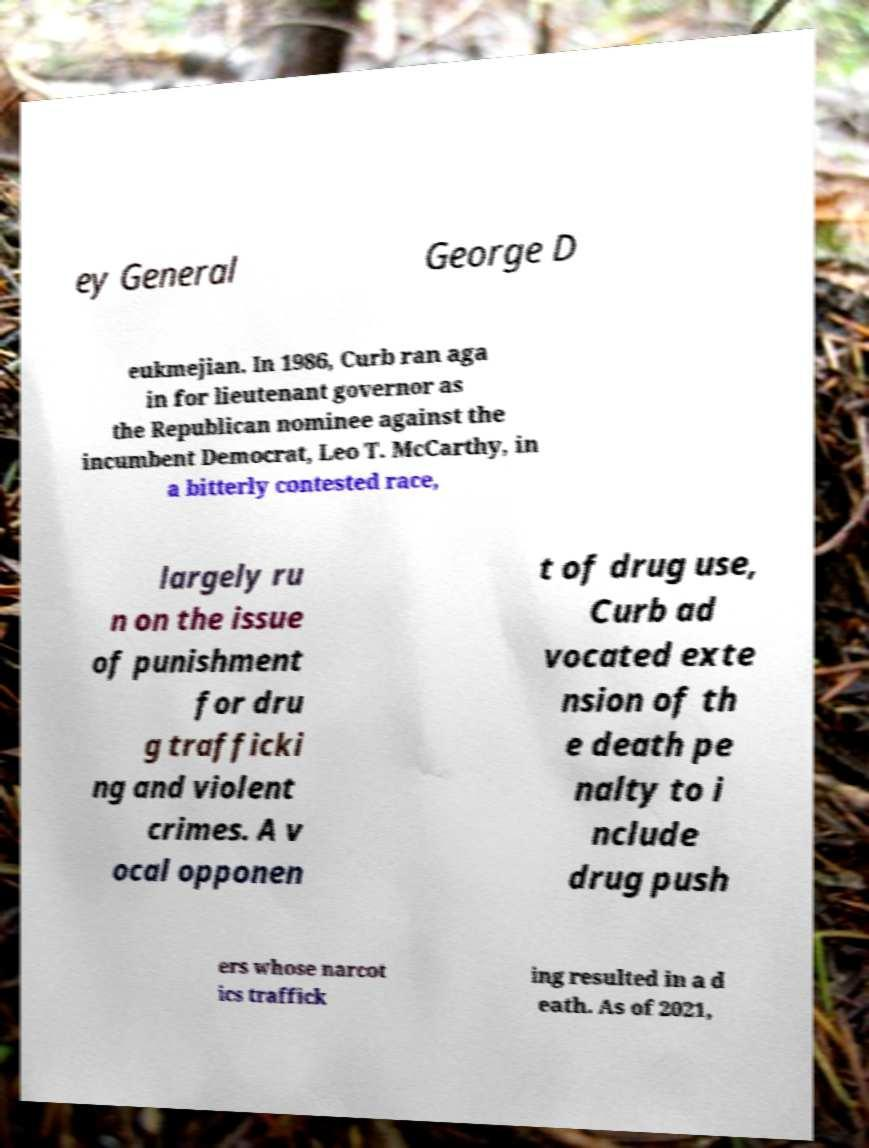What messages or text are displayed in this image? I need them in a readable, typed format. ey General George D eukmejian. In 1986, Curb ran aga in for lieutenant governor as the Republican nominee against the incumbent Democrat, Leo T. McCarthy, in a bitterly contested race, largely ru n on the issue of punishment for dru g trafficki ng and violent crimes. A v ocal opponen t of drug use, Curb ad vocated exte nsion of th e death pe nalty to i nclude drug push ers whose narcot ics traffick ing resulted in a d eath. As of 2021, 